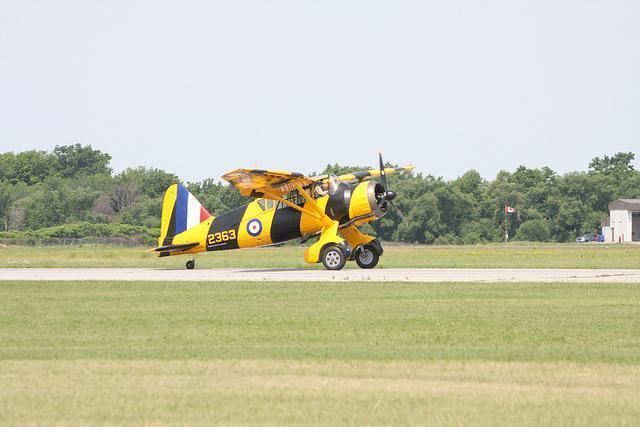How many bikes are there?
Give a very brief answer. 0. 